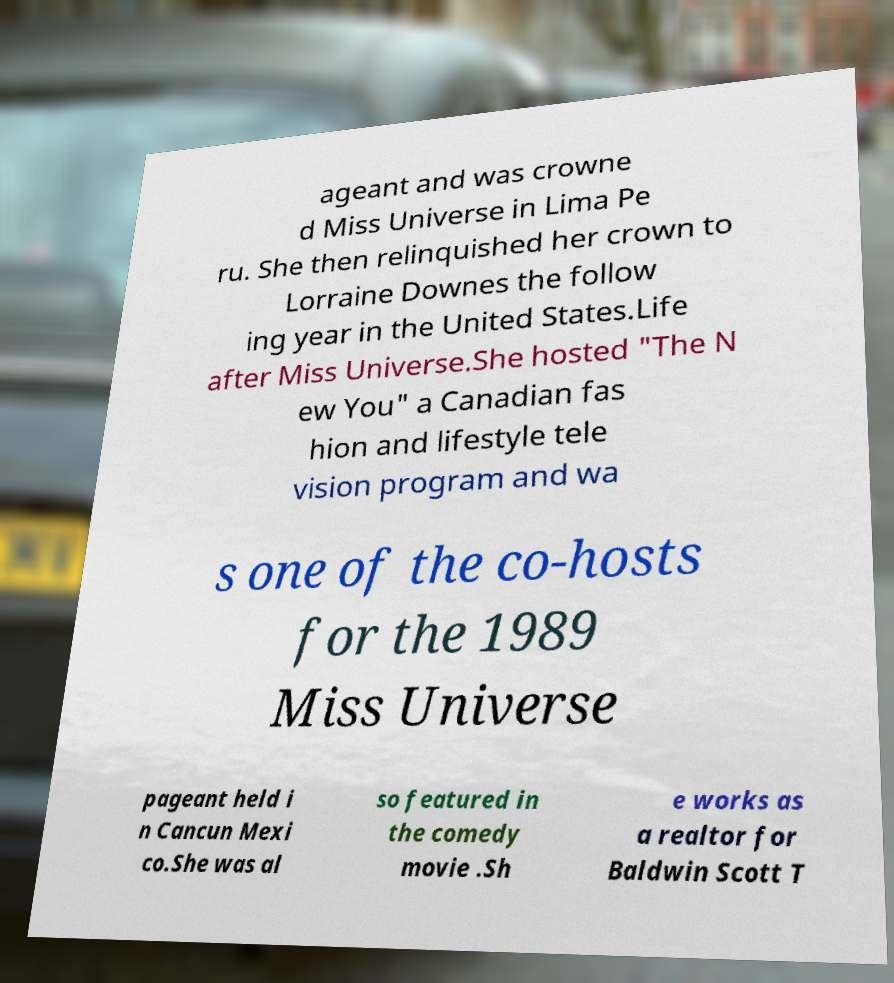Could you assist in decoding the text presented in this image and type it out clearly? ageant and was crowne d Miss Universe in Lima Pe ru. She then relinquished her crown to Lorraine Downes the follow ing year in the United States.Life after Miss Universe.She hosted "The N ew You" a Canadian fas hion and lifestyle tele vision program and wa s one of the co-hosts for the 1989 Miss Universe pageant held i n Cancun Mexi co.She was al so featured in the comedy movie .Sh e works as a realtor for Baldwin Scott T 